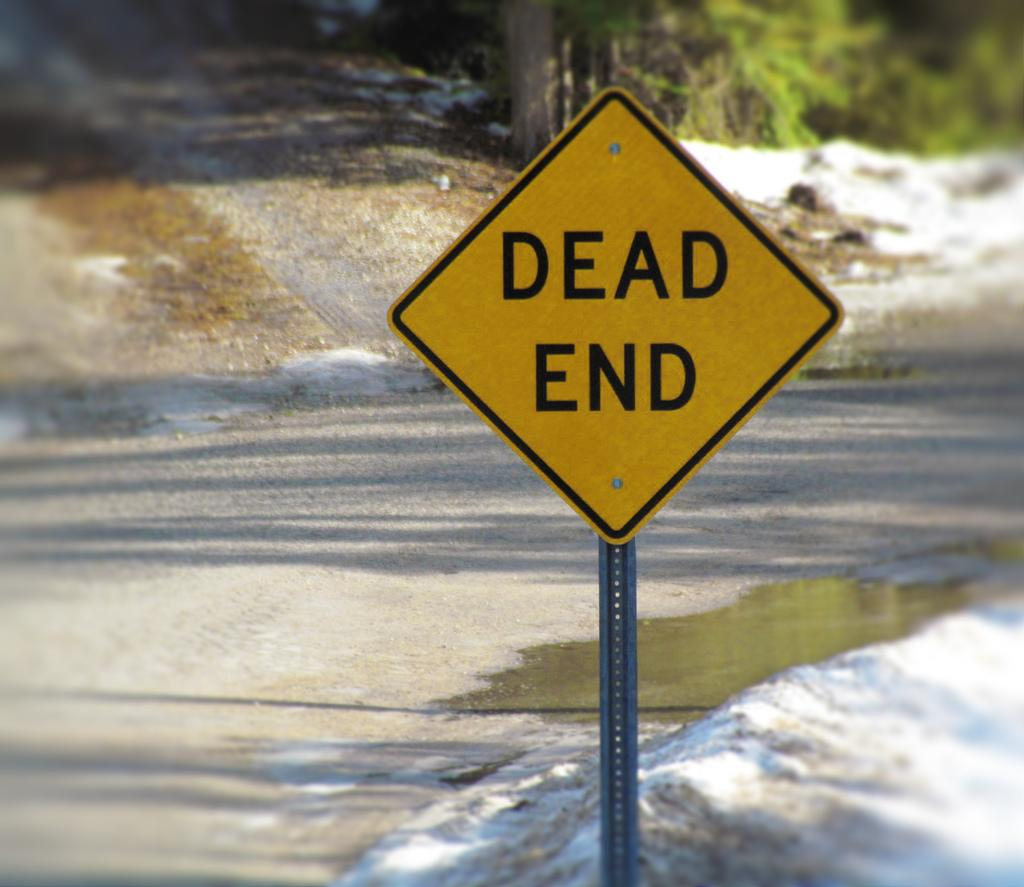Provide a one-sentence caption for the provided image. A yellow sign tells you the street is a dead end. 